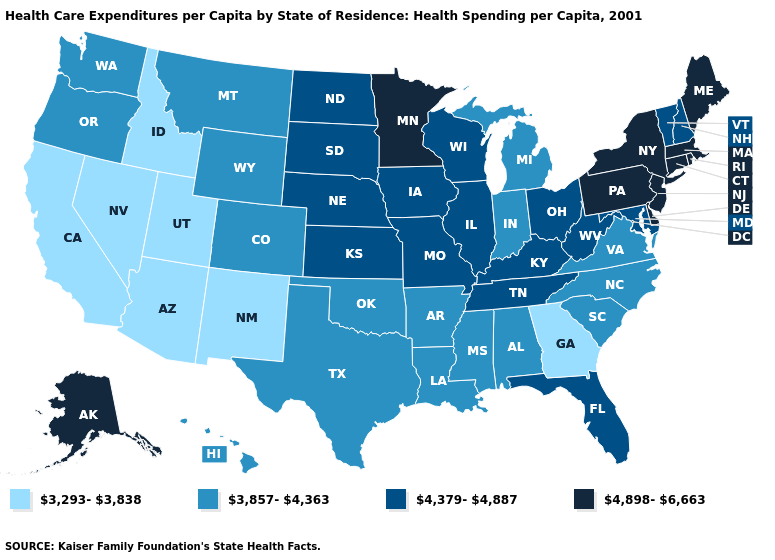What is the highest value in states that border Iowa?
Keep it brief. 4,898-6,663. Does Texas have a lower value than Wyoming?
Answer briefly. No. Which states have the highest value in the USA?
Be succinct. Alaska, Connecticut, Delaware, Maine, Massachusetts, Minnesota, New Jersey, New York, Pennsylvania, Rhode Island. Name the states that have a value in the range 4,379-4,887?
Be succinct. Florida, Illinois, Iowa, Kansas, Kentucky, Maryland, Missouri, Nebraska, New Hampshire, North Dakota, Ohio, South Dakota, Tennessee, Vermont, West Virginia, Wisconsin. What is the value of Maine?
Be succinct. 4,898-6,663. Among the states that border Missouri , does Arkansas have the lowest value?
Concise answer only. Yes. What is the value of Maine?
Give a very brief answer. 4,898-6,663. What is the lowest value in states that border Montana?
Concise answer only. 3,293-3,838. Among the states that border Michigan , which have the highest value?
Write a very short answer. Ohio, Wisconsin. What is the value of New Mexico?
Write a very short answer. 3,293-3,838. Name the states that have a value in the range 3,293-3,838?
Write a very short answer. Arizona, California, Georgia, Idaho, Nevada, New Mexico, Utah. What is the lowest value in the Northeast?
Short answer required. 4,379-4,887. What is the value of Nebraska?
Keep it brief. 4,379-4,887. Does Minnesota have the highest value in the MidWest?
Concise answer only. Yes. Name the states that have a value in the range 4,898-6,663?
Answer briefly. Alaska, Connecticut, Delaware, Maine, Massachusetts, Minnesota, New Jersey, New York, Pennsylvania, Rhode Island. 